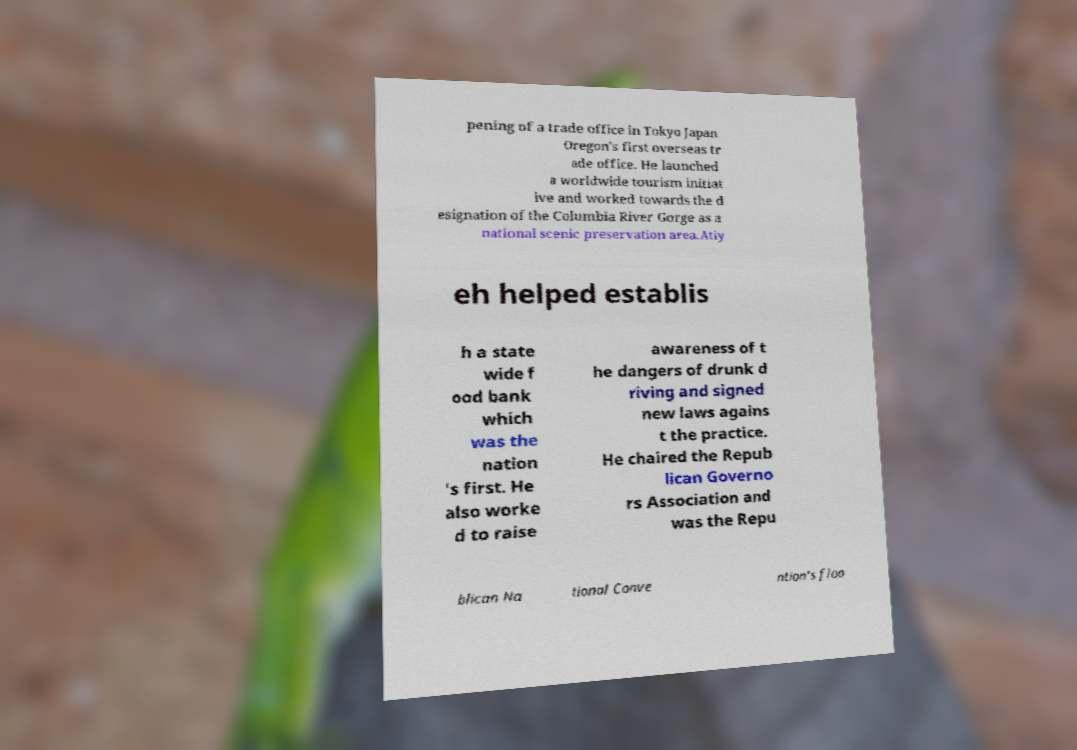For documentation purposes, I need the text within this image transcribed. Could you provide that? pening of a trade office in Tokyo Japan Oregon's first overseas tr ade office. He launched a worldwide tourism initiat ive and worked towards the d esignation of the Columbia River Gorge as a national scenic preservation area.Atiy eh helped establis h a state wide f ood bank which was the nation 's first. He also worke d to raise awareness of t he dangers of drunk d riving and signed new laws agains t the practice. He chaired the Repub lican Governo rs Association and was the Repu blican Na tional Conve ntion's floo 